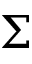Convert formula to latex. <formula><loc_0><loc_0><loc_500><loc_500>\Sigma</formula> 